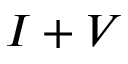<formula> <loc_0><loc_0><loc_500><loc_500>I + V</formula> 